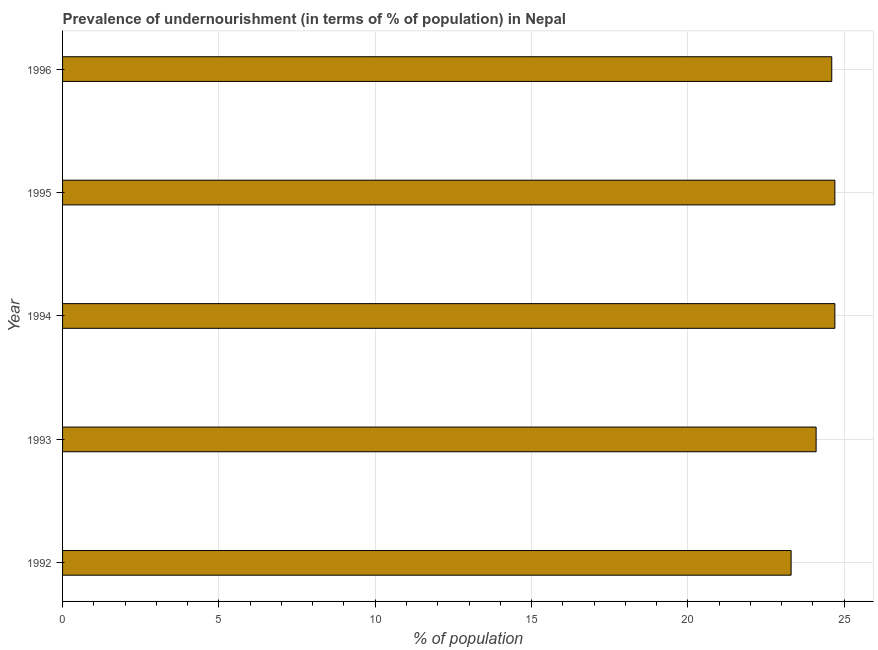Does the graph contain any zero values?
Your answer should be very brief. No. Does the graph contain grids?
Your response must be concise. Yes. What is the title of the graph?
Give a very brief answer. Prevalence of undernourishment (in terms of % of population) in Nepal. What is the label or title of the X-axis?
Keep it short and to the point. % of population. What is the label or title of the Y-axis?
Make the answer very short. Year. What is the percentage of undernourished population in 1995?
Your answer should be very brief. 24.7. Across all years, what is the maximum percentage of undernourished population?
Provide a short and direct response. 24.7. Across all years, what is the minimum percentage of undernourished population?
Provide a short and direct response. 23.3. In which year was the percentage of undernourished population minimum?
Give a very brief answer. 1992. What is the sum of the percentage of undernourished population?
Give a very brief answer. 121.4. What is the average percentage of undernourished population per year?
Make the answer very short. 24.28. What is the median percentage of undernourished population?
Give a very brief answer. 24.6. In how many years, is the percentage of undernourished population greater than 19 %?
Your answer should be compact. 5. What is the ratio of the percentage of undernourished population in 1993 to that in 1995?
Your answer should be compact. 0.98. Is the percentage of undernourished population in 1994 less than that in 1996?
Your response must be concise. No. Is the difference between the percentage of undernourished population in 1994 and 1996 greater than the difference between any two years?
Keep it short and to the point. No. Is the sum of the percentage of undernourished population in 1993 and 1995 greater than the maximum percentage of undernourished population across all years?
Provide a short and direct response. Yes. How many bars are there?
Your answer should be compact. 5. Are the values on the major ticks of X-axis written in scientific E-notation?
Your answer should be very brief. No. What is the % of population in 1992?
Give a very brief answer. 23.3. What is the % of population in 1993?
Provide a short and direct response. 24.1. What is the % of population of 1994?
Your answer should be very brief. 24.7. What is the % of population of 1995?
Offer a very short reply. 24.7. What is the % of population in 1996?
Your answer should be very brief. 24.6. What is the difference between the % of population in 1992 and 1993?
Give a very brief answer. -0.8. What is the difference between the % of population in 1992 and 1995?
Offer a terse response. -1.4. What is the difference between the % of population in 1992 and 1996?
Offer a very short reply. -1.3. What is the difference between the % of population in 1993 and 1994?
Provide a succinct answer. -0.6. What is the difference between the % of population in 1993 and 1996?
Ensure brevity in your answer.  -0.5. What is the ratio of the % of population in 1992 to that in 1994?
Give a very brief answer. 0.94. What is the ratio of the % of population in 1992 to that in 1995?
Offer a terse response. 0.94. What is the ratio of the % of population in 1992 to that in 1996?
Your answer should be compact. 0.95. What is the ratio of the % of population in 1993 to that in 1994?
Ensure brevity in your answer.  0.98. What is the ratio of the % of population in 1993 to that in 1996?
Ensure brevity in your answer.  0.98. What is the ratio of the % of population in 1994 to that in 1995?
Your response must be concise. 1. What is the ratio of the % of population in 1994 to that in 1996?
Provide a succinct answer. 1. 